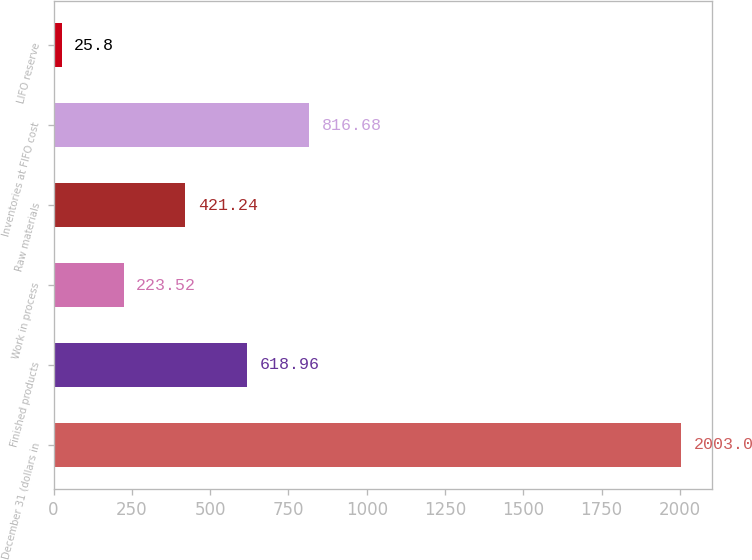<chart> <loc_0><loc_0><loc_500><loc_500><bar_chart><fcel>December 31 (dollars in<fcel>Finished products<fcel>Work in process<fcel>Raw materials<fcel>Inventories at FIFO cost<fcel>LIFO reserve<nl><fcel>2003<fcel>618.96<fcel>223.52<fcel>421.24<fcel>816.68<fcel>25.8<nl></chart> 